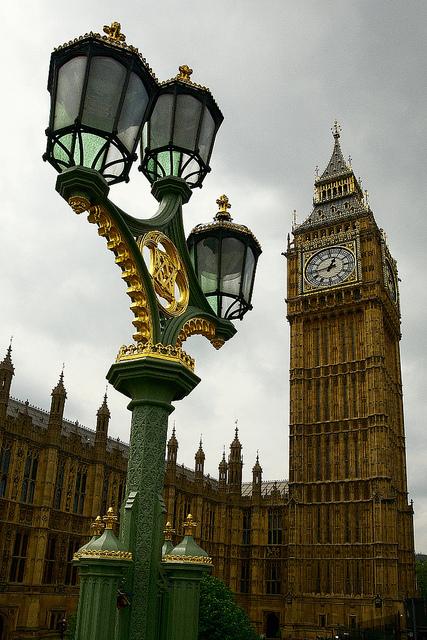What is wrapped around the pole?
Keep it brief. Nothing. What color of the lamppost?
Concise answer only. Green. What kind of weather it is?
Short answer required. Cloudy. Is there a clock in the picture?
Concise answer only. Yes. 